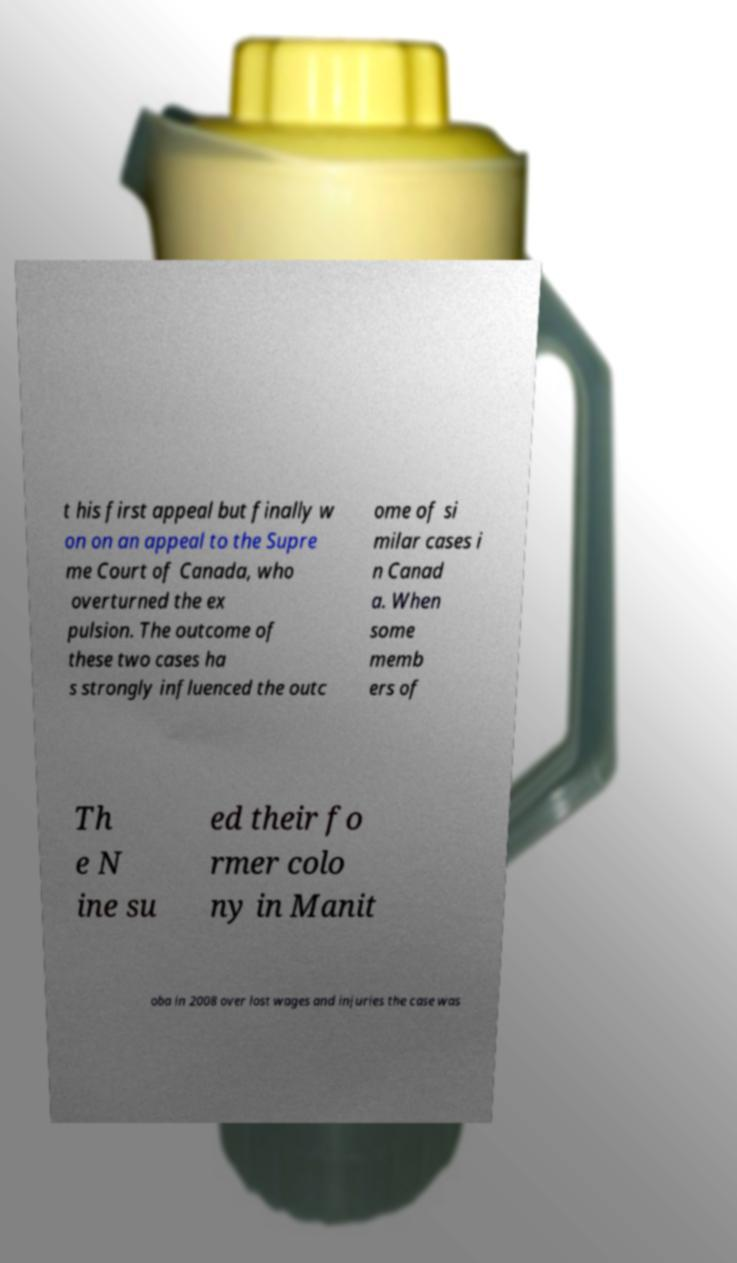What messages or text are displayed in this image? I need them in a readable, typed format. t his first appeal but finally w on on an appeal to the Supre me Court of Canada, who overturned the ex pulsion. The outcome of these two cases ha s strongly influenced the outc ome of si milar cases i n Canad a. When some memb ers of Th e N ine su ed their fo rmer colo ny in Manit oba in 2008 over lost wages and injuries the case was 